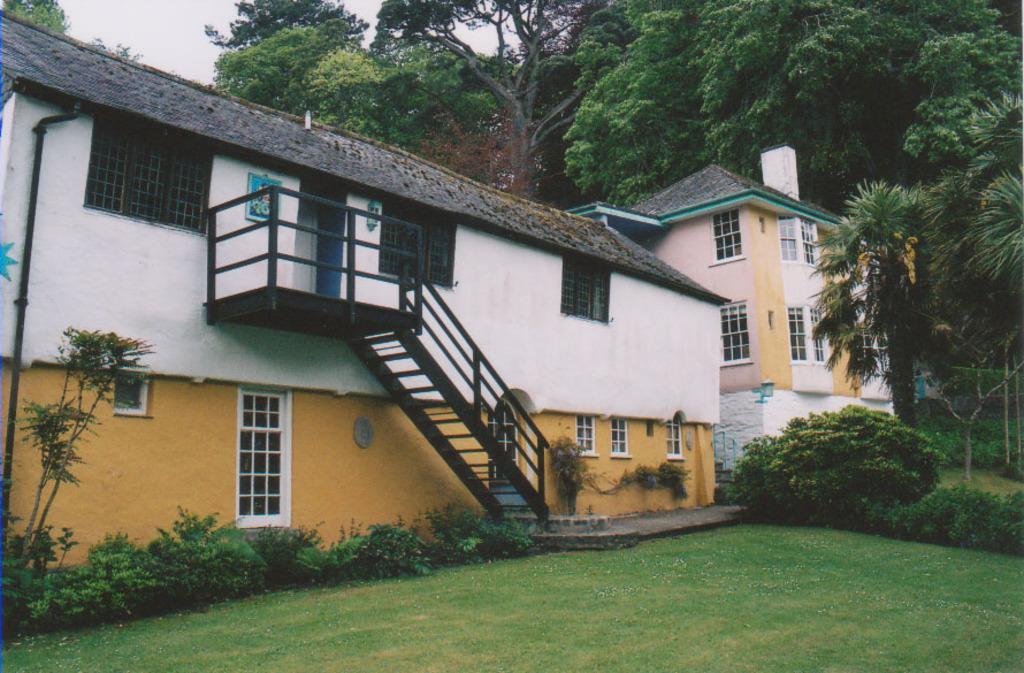How would you summarize this image in a sentence or two? In this image I can see the ground, few plants, few stairs, few buildings, few windows of the buildings and few trees which are green in color. In the background I can see the sky. 